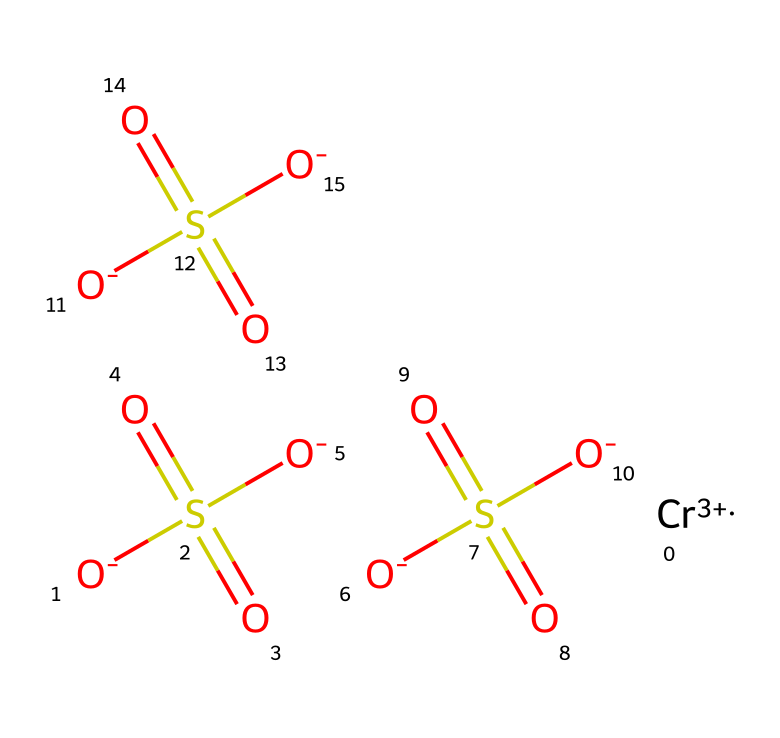What is the central metal ion in this coordination compound? The structure shows a chromium ion with a +3 oxidation state, which is the central metal of the coordination compound as indicated by [Cr+3].
Answer: chromium How many sulfate groups are present in this compound? The chemical contains three separate sulfate groups, each represented by [O-]S(=O)(=O)[O-]. Counting them gives us the total number.
Answer: three What is the oxidation state of chromium in this compound? The notation [Cr+3] indicates that chromium has a +3 oxidation state, as explicitly stated in the chemical notation.
Answer: +3 What type of bonding is primarily present in this compound? The compound demonstrates coordination bonding involving the chromium ion at the center and the sulfate groups surrounding it, characterized by strong ionic interactions.
Answer: coordination Which functional groups are present in this complex? The presence of multiple sulfate groups indicates that the functional groups in this compound are sulfonates, derived from sulfuric acid.
Answer: sulfonates How many total sulfate oxygens are present in this compound? Each sulfate group contains four oxygen atoms, and with three sulfate groups, the total number of oxygen atoms is 3 groups x 4 oxygens each = 12.
Answer: twelve 